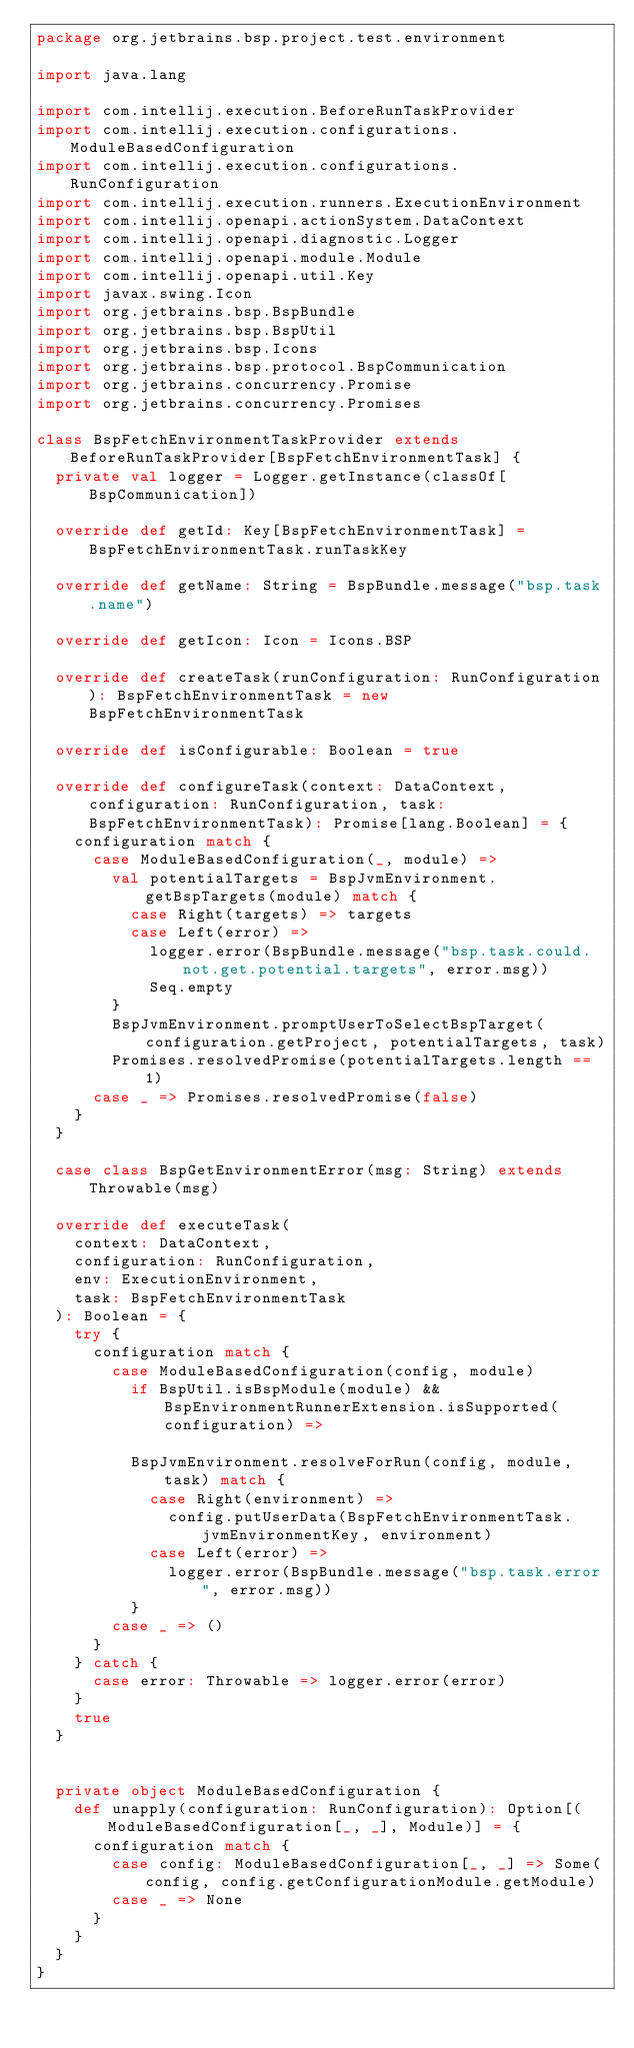Convert code to text. <code><loc_0><loc_0><loc_500><loc_500><_Scala_>package org.jetbrains.bsp.project.test.environment

import java.lang

import com.intellij.execution.BeforeRunTaskProvider
import com.intellij.execution.configurations.ModuleBasedConfiguration
import com.intellij.execution.configurations.RunConfiguration
import com.intellij.execution.runners.ExecutionEnvironment
import com.intellij.openapi.actionSystem.DataContext
import com.intellij.openapi.diagnostic.Logger
import com.intellij.openapi.module.Module
import com.intellij.openapi.util.Key
import javax.swing.Icon
import org.jetbrains.bsp.BspBundle
import org.jetbrains.bsp.BspUtil
import org.jetbrains.bsp.Icons
import org.jetbrains.bsp.protocol.BspCommunication
import org.jetbrains.concurrency.Promise
import org.jetbrains.concurrency.Promises

class BspFetchEnvironmentTaskProvider extends BeforeRunTaskProvider[BspFetchEnvironmentTask] {
  private val logger = Logger.getInstance(classOf[BspCommunication])

  override def getId: Key[BspFetchEnvironmentTask] = BspFetchEnvironmentTask.runTaskKey

  override def getName: String = BspBundle.message("bsp.task.name")

  override def getIcon: Icon = Icons.BSP

  override def createTask(runConfiguration: RunConfiguration): BspFetchEnvironmentTask = new BspFetchEnvironmentTask

  override def isConfigurable: Boolean = true

  override def configureTask(context: DataContext, configuration: RunConfiguration, task: BspFetchEnvironmentTask): Promise[lang.Boolean] = {
    configuration match {
      case ModuleBasedConfiguration(_, module) =>
        val potentialTargets = BspJvmEnvironment.getBspTargets(module) match {
          case Right(targets) => targets
          case Left(error) =>
            logger.error(BspBundle.message("bsp.task.could.not.get.potential.targets", error.msg))
            Seq.empty
        }
        BspJvmEnvironment.promptUserToSelectBspTarget(configuration.getProject, potentialTargets, task)
        Promises.resolvedPromise(potentialTargets.length == 1)
      case _ => Promises.resolvedPromise(false)
    }
  }

  case class BspGetEnvironmentError(msg: String) extends Throwable(msg)

  override def executeTask(
    context: DataContext,
    configuration: RunConfiguration,
    env: ExecutionEnvironment,
    task: BspFetchEnvironmentTask
  ): Boolean = {
    try {
      configuration match {
        case ModuleBasedConfiguration(config, module)
          if BspUtil.isBspModule(module) && BspEnvironmentRunnerExtension.isSupported(configuration) =>

          BspJvmEnvironment.resolveForRun(config, module, task) match {
            case Right(environment) =>
              config.putUserData(BspFetchEnvironmentTask.jvmEnvironmentKey, environment)
            case Left(error) =>
              logger.error(BspBundle.message("bsp.task.error", error.msg))
          }
        case _ => ()
      }
    } catch {
      case error: Throwable => logger.error(error)
    }
    true
  }


  private object ModuleBasedConfiguration {
    def unapply(configuration: RunConfiguration): Option[(ModuleBasedConfiguration[_, _], Module)] = {
      configuration match {
        case config: ModuleBasedConfiguration[_, _] => Some(config, config.getConfigurationModule.getModule)
        case _ => None
      }
    }
  }
}
</code> 